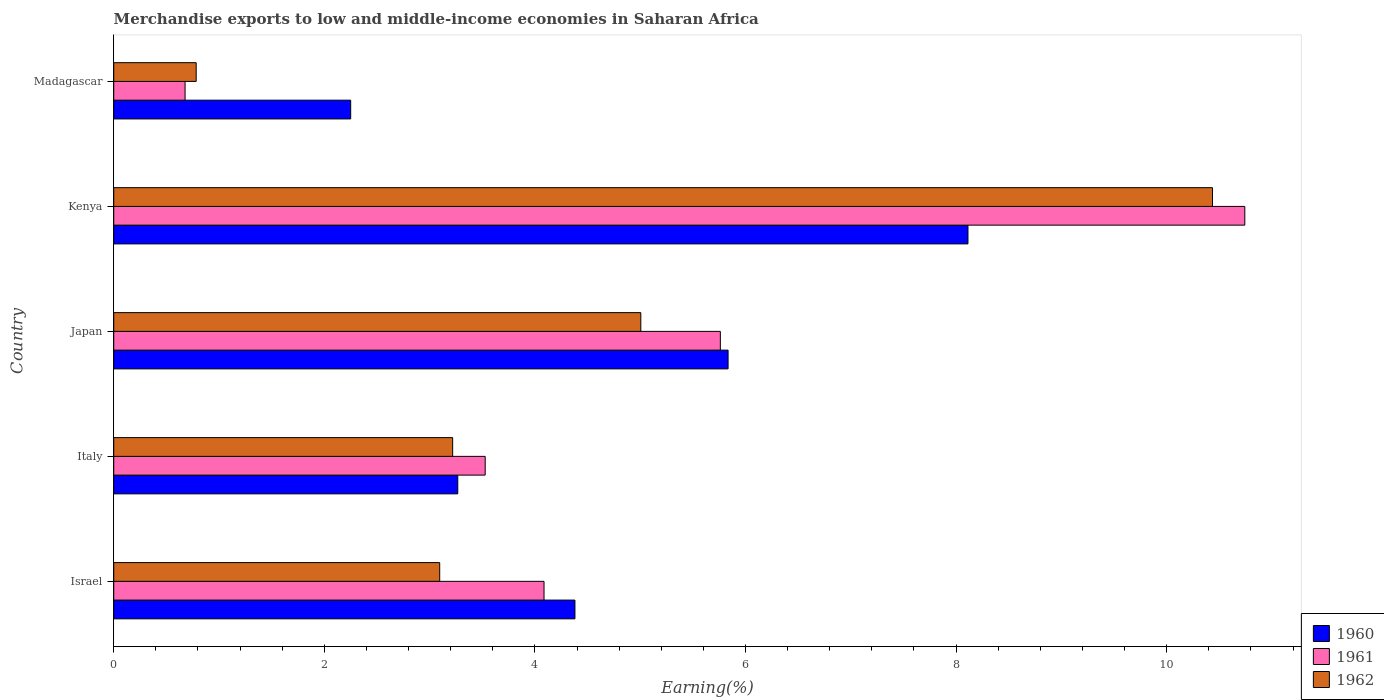How many groups of bars are there?
Make the answer very short. 5. Are the number of bars on each tick of the Y-axis equal?
Your response must be concise. Yes. How many bars are there on the 2nd tick from the top?
Ensure brevity in your answer.  3. What is the label of the 2nd group of bars from the top?
Provide a short and direct response. Kenya. In how many cases, is the number of bars for a given country not equal to the number of legend labels?
Keep it short and to the point. 0. What is the percentage of amount earned from merchandise exports in 1961 in Israel?
Provide a short and direct response. 4.09. Across all countries, what is the maximum percentage of amount earned from merchandise exports in 1962?
Your answer should be compact. 10.44. Across all countries, what is the minimum percentage of amount earned from merchandise exports in 1960?
Ensure brevity in your answer.  2.25. In which country was the percentage of amount earned from merchandise exports in 1961 maximum?
Make the answer very short. Kenya. In which country was the percentage of amount earned from merchandise exports in 1960 minimum?
Provide a succinct answer. Madagascar. What is the total percentage of amount earned from merchandise exports in 1962 in the graph?
Your answer should be compact. 22.54. What is the difference between the percentage of amount earned from merchandise exports in 1962 in Israel and that in Japan?
Provide a succinct answer. -1.91. What is the difference between the percentage of amount earned from merchandise exports in 1960 in Israel and the percentage of amount earned from merchandise exports in 1961 in Madagascar?
Ensure brevity in your answer.  3.7. What is the average percentage of amount earned from merchandise exports in 1960 per country?
Your response must be concise. 4.77. What is the difference between the percentage of amount earned from merchandise exports in 1960 and percentage of amount earned from merchandise exports in 1961 in Italy?
Provide a short and direct response. -0.26. What is the ratio of the percentage of amount earned from merchandise exports in 1962 in Israel to that in Japan?
Provide a succinct answer. 0.62. Is the percentage of amount earned from merchandise exports in 1960 in Italy less than that in Japan?
Your answer should be compact. Yes. Is the difference between the percentage of amount earned from merchandise exports in 1960 in Italy and Madagascar greater than the difference between the percentage of amount earned from merchandise exports in 1961 in Italy and Madagascar?
Make the answer very short. No. What is the difference between the highest and the second highest percentage of amount earned from merchandise exports in 1961?
Your response must be concise. 4.98. What is the difference between the highest and the lowest percentage of amount earned from merchandise exports in 1961?
Provide a short and direct response. 10.06. What does the 2nd bar from the top in Madagascar represents?
Provide a succinct answer. 1961. Is it the case that in every country, the sum of the percentage of amount earned from merchandise exports in 1960 and percentage of amount earned from merchandise exports in 1961 is greater than the percentage of amount earned from merchandise exports in 1962?
Provide a short and direct response. Yes. How many bars are there?
Ensure brevity in your answer.  15. How many countries are there in the graph?
Provide a succinct answer. 5. Does the graph contain any zero values?
Make the answer very short. No. How many legend labels are there?
Provide a succinct answer. 3. How are the legend labels stacked?
Offer a terse response. Vertical. What is the title of the graph?
Your answer should be very brief. Merchandise exports to low and middle-income economies in Saharan Africa. What is the label or title of the X-axis?
Your answer should be very brief. Earning(%). What is the Earning(%) of 1960 in Israel?
Keep it short and to the point. 4.38. What is the Earning(%) in 1961 in Israel?
Keep it short and to the point. 4.09. What is the Earning(%) of 1962 in Israel?
Ensure brevity in your answer.  3.1. What is the Earning(%) in 1960 in Italy?
Your answer should be very brief. 3.27. What is the Earning(%) in 1961 in Italy?
Your answer should be very brief. 3.53. What is the Earning(%) of 1962 in Italy?
Your response must be concise. 3.22. What is the Earning(%) in 1960 in Japan?
Offer a very short reply. 5.83. What is the Earning(%) in 1961 in Japan?
Provide a succinct answer. 5.76. What is the Earning(%) in 1962 in Japan?
Offer a very short reply. 5.01. What is the Earning(%) of 1960 in Kenya?
Give a very brief answer. 8.11. What is the Earning(%) of 1961 in Kenya?
Make the answer very short. 10.74. What is the Earning(%) of 1962 in Kenya?
Provide a succinct answer. 10.44. What is the Earning(%) in 1960 in Madagascar?
Make the answer very short. 2.25. What is the Earning(%) in 1961 in Madagascar?
Give a very brief answer. 0.68. What is the Earning(%) of 1962 in Madagascar?
Give a very brief answer. 0.78. Across all countries, what is the maximum Earning(%) of 1960?
Ensure brevity in your answer.  8.11. Across all countries, what is the maximum Earning(%) of 1961?
Provide a succinct answer. 10.74. Across all countries, what is the maximum Earning(%) in 1962?
Ensure brevity in your answer.  10.44. Across all countries, what is the minimum Earning(%) of 1960?
Provide a short and direct response. 2.25. Across all countries, what is the minimum Earning(%) in 1961?
Give a very brief answer. 0.68. Across all countries, what is the minimum Earning(%) of 1962?
Your answer should be very brief. 0.78. What is the total Earning(%) of 1960 in the graph?
Your answer should be compact. 23.85. What is the total Earning(%) of 1961 in the graph?
Keep it short and to the point. 24.8. What is the total Earning(%) of 1962 in the graph?
Keep it short and to the point. 22.54. What is the difference between the Earning(%) of 1960 in Israel and that in Italy?
Offer a terse response. 1.11. What is the difference between the Earning(%) in 1961 in Israel and that in Italy?
Give a very brief answer. 0.56. What is the difference between the Earning(%) in 1962 in Israel and that in Italy?
Make the answer very short. -0.12. What is the difference between the Earning(%) of 1960 in Israel and that in Japan?
Give a very brief answer. -1.45. What is the difference between the Earning(%) of 1961 in Israel and that in Japan?
Your answer should be very brief. -1.67. What is the difference between the Earning(%) in 1962 in Israel and that in Japan?
Provide a succinct answer. -1.91. What is the difference between the Earning(%) in 1960 in Israel and that in Kenya?
Keep it short and to the point. -3.73. What is the difference between the Earning(%) of 1961 in Israel and that in Kenya?
Offer a very short reply. -6.66. What is the difference between the Earning(%) in 1962 in Israel and that in Kenya?
Your answer should be very brief. -7.34. What is the difference between the Earning(%) in 1960 in Israel and that in Madagascar?
Provide a succinct answer. 2.13. What is the difference between the Earning(%) of 1961 in Israel and that in Madagascar?
Keep it short and to the point. 3.41. What is the difference between the Earning(%) in 1962 in Israel and that in Madagascar?
Provide a short and direct response. 2.31. What is the difference between the Earning(%) of 1960 in Italy and that in Japan?
Provide a short and direct response. -2.57. What is the difference between the Earning(%) of 1961 in Italy and that in Japan?
Keep it short and to the point. -2.23. What is the difference between the Earning(%) of 1962 in Italy and that in Japan?
Your answer should be very brief. -1.79. What is the difference between the Earning(%) of 1960 in Italy and that in Kenya?
Offer a very short reply. -4.85. What is the difference between the Earning(%) in 1961 in Italy and that in Kenya?
Provide a succinct answer. -7.21. What is the difference between the Earning(%) of 1962 in Italy and that in Kenya?
Provide a short and direct response. -7.22. What is the difference between the Earning(%) in 1960 in Italy and that in Madagascar?
Provide a succinct answer. 1.02. What is the difference between the Earning(%) of 1961 in Italy and that in Madagascar?
Keep it short and to the point. 2.85. What is the difference between the Earning(%) in 1962 in Italy and that in Madagascar?
Provide a succinct answer. 2.44. What is the difference between the Earning(%) of 1960 in Japan and that in Kenya?
Keep it short and to the point. -2.28. What is the difference between the Earning(%) in 1961 in Japan and that in Kenya?
Keep it short and to the point. -4.98. What is the difference between the Earning(%) of 1962 in Japan and that in Kenya?
Your response must be concise. -5.43. What is the difference between the Earning(%) in 1960 in Japan and that in Madagascar?
Provide a short and direct response. 3.58. What is the difference between the Earning(%) of 1961 in Japan and that in Madagascar?
Ensure brevity in your answer.  5.08. What is the difference between the Earning(%) of 1962 in Japan and that in Madagascar?
Your response must be concise. 4.22. What is the difference between the Earning(%) in 1960 in Kenya and that in Madagascar?
Ensure brevity in your answer.  5.86. What is the difference between the Earning(%) in 1961 in Kenya and that in Madagascar?
Provide a short and direct response. 10.06. What is the difference between the Earning(%) of 1962 in Kenya and that in Madagascar?
Make the answer very short. 9.65. What is the difference between the Earning(%) in 1960 in Israel and the Earning(%) in 1961 in Italy?
Offer a terse response. 0.85. What is the difference between the Earning(%) in 1960 in Israel and the Earning(%) in 1962 in Italy?
Offer a very short reply. 1.16. What is the difference between the Earning(%) in 1961 in Israel and the Earning(%) in 1962 in Italy?
Offer a very short reply. 0.87. What is the difference between the Earning(%) in 1960 in Israel and the Earning(%) in 1961 in Japan?
Give a very brief answer. -1.38. What is the difference between the Earning(%) of 1960 in Israel and the Earning(%) of 1962 in Japan?
Offer a very short reply. -0.63. What is the difference between the Earning(%) of 1961 in Israel and the Earning(%) of 1962 in Japan?
Provide a succinct answer. -0.92. What is the difference between the Earning(%) in 1960 in Israel and the Earning(%) in 1961 in Kenya?
Keep it short and to the point. -6.36. What is the difference between the Earning(%) of 1960 in Israel and the Earning(%) of 1962 in Kenya?
Keep it short and to the point. -6.06. What is the difference between the Earning(%) of 1961 in Israel and the Earning(%) of 1962 in Kenya?
Provide a short and direct response. -6.35. What is the difference between the Earning(%) in 1960 in Israel and the Earning(%) in 1961 in Madagascar?
Give a very brief answer. 3.7. What is the difference between the Earning(%) in 1960 in Israel and the Earning(%) in 1962 in Madagascar?
Provide a succinct answer. 3.6. What is the difference between the Earning(%) in 1961 in Israel and the Earning(%) in 1962 in Madagascar?
Make the answer very short. 3.3. What is the difference between the Earning(%) in 1960 in Italy and the Earning(%) in 1961 in Japan?
Your answer should be very brief. -2.49. What is the difference between the Earning(%) of 1960 in Italy and the Earning(%) of 1962 in Japan?
Provide a short and direct response. -1.74. What is the difference between the Earning(%) in 1961 in Italy and the Earning(%) in 1962 in Japan?
Ensure brevity in your answer.  -1.48. What is the difference between the Earning(%) of 1960 in Italy and the Earning(%) of 1961 in Kenya?
Your answer should be compact. -7.47. What is the difference between the Earning(%) in 1960 in Italy and the Earning(%) in 1962 in Kenya?
Offer a very short reply. -7.17. What is the difference between the Earning(%) of 1961 in Italy and the Earning(%) of 1962 in Kenya?
Your response must be concise. -6.91. What is the difference between the Earning(%) in 1960 in Italy and the Earning(%) in 1961 in Madagascar?
Provide a short and direct response. 2.59. What is the difference between the Earning(%) in 1960 in Italy and the Earning(%) in 1962 in Madagascar?
Make the answer very short. 2.48. What is the difference between the Earning(%) in 1961 in Italy and the Earning(%) in 1962 in Madagascar?
Your answer should be compact. 2.74. What is the difference between the Earning(%) of 1960 in Japan and the Earning(%) of 1961 in Kenya?
Offer a terse response. -4.91. What is the difference between the Earning(%) of 1960 in Japan and the Earning(%) of 1962 in Kenya?
Ensure brevity in your answer.  -4.6. What is the difference between the Earning(%) in 1961 in Japan and the Earning(%) in 1962 in Kenya?
Provide a short and direct response. -4.67. What is the difference between the Earning(%) in 1960 in Japan and the Earning(%) in 1961 in Madagascar?
Your response must be concise. 5.16. What is the difference between the Earning(%) of 1960 in Japan and the Earning(%) of 1962 in Madagascar?
Your answer should be very brief. 5.05. What is the difference between the Earning(%) of 1961 in Japan and the Earning(%) of 1962 in Madagascar?
Your response must be concise. 4.98. What is the difference between the Earning(%) of 1960 in Kenya and the Earning(%) of 1961 in Madagascar?
Keep it short and to the point. 7.44. What is the difference between the Earning(%) of 1960 in Kenya and the Earning(%) of 1962 in Madagascar?
Offer a very short reply. 7.33. What is the difference between the Earning(%) of 1961 in Kenya and the Earning(%) of 1962 in Madagascar?
Keep it short and to the point. 9.96. What is the average Earning(%) in 1960 per country?
Make the answer very short. 4.77. What is the average Earning(%) of 1961 per country?
Make the answer very short. 4.96. What is the average Earning(%) in 1962 per country?
Make the answer very short. 4.51. What is the difference between the Earning(%) of 1960 and Earning(%) of 1961 in Israel?
Give a very brief answer. 0.29. What is the difference between the Earning(%) of 1960 and Earning(%) of 1962 in Israel?
Give a very brief answer. 1.28. What is the difference between the Earning(%) in 1961 and Earning(%) in 1962 in Israel?
Ensure brevity in your answer.  0.99. What is the difference between the Earning(%) in 1960 and Earning(%) in 1961 in Italy?
Your response must be concise. -0.26. What is the difference between the Earning(%) of 1960 and Earning(%) of 1962 in Italy?
Ensure brevity in your answer.  0.05. What is the difference between the Earning(%) in 1961 and Earning(%) in 1962 in Italy?
Provide a short and direct response. 0.31. What is the difference between the Earning(%) of 1960 and Earning(%) of 1961 in Japan?
Your response must be concise. 0.07. What is the difference between the Earning(%) of 1960 and Earning(%) of 1962 in Japan?
Offer a terse response. 0.83. What is the difference between the Earning(%) of 1961 and Earning(%) of 1962 in Japan?
Keep it short and to the point. 0.76. What is the difference between the Earning(%) in 1960 and Earning(%) in 1961 in Kenya?
Make the answer very short. -2.63. What is the difference between the Earning(%) in 1960 and Earning(%) in 1962 in Kenya?
Make the answer very short. -2.32. What is the difference between the Earning(%) in 1961 and Earning(%) in 1962 in Kenya?
Offer a very short reply. 0.31. What is the difference between the Earning(%) in 1960 and Earning(%) in 1961 in Madagascar?
Provide a short and direct response. 1.57. What is the difference between the Earning(%) in 1960 and Earning(%) in 1962 in Madagascar?
Your answer should be very brief. 1.47. What is the difference between the Earning(%) in 1961 and Earning(%) in 1962 in Madagascar?
Provide a short and direct response. -0.11. What is the ratio of the Earning(%) of 1960 in Israel to that in Italy?
Provide a short and direct response. 1.34. What is the ratio of the Earning(%) of 1961 in Israel to that in Italy?
Provide a short and direct response. 1.16. What is the ratio of the Earning(%) in 1962 in Israel to that in Italy?
Offer a terse response. 0.96. What is the ratio of the Earning(%) of 1960 in Israel to that in Japan?
Your answer should be very brief. 0.75. What is the ratio of the Earning(%) in 1961 in Israel to that in Japan?
Give a very brief answer. 0.71. What is the ratio of the Earning(%) in 1962 in Israel to that in Japan?
Your answer should be very brief. 0.62. What is the ratio of the Earning(%) of 1960 in Israel to that in Kenya?
Offer a terse response. 0.54. What is the ratio of the Earning(%) of 1961 in Israel to that in Kenya?
Offer a very short reply. 0.38. What is the ratio of the Earning(%) of 1962 in Israel to that in Kenya?
Your response must be concise. 0.3. What is the ratio of the Earning(%) of 1960 in Israel to that in Madagascar?
Your answer should be very brief. 1.95. What is the ratio of the Earning(%) of 1961 in Israel to that in Madagascar?
Make the answer very short. 6.03. What is the ratio of the Earning(%) in 1962 in Israel to that in Madagascar?
Keep it short and to the point. 3.95. What is the ratio of the Earning(%) of 1960 in Italy to that in Japan?
Offer a terse response. 0.56. What is the ratio of the Earning(%) of 1961 in Italy to that in Japan?
Provide a short and direct response. 0.61. What is the ratio of the Earning(%) of 1962 in Italy to that in Japan?
Your answer should be compact. 0.64. What is the ratio of the Earning(%) of 1960 in Italy to that in Kenya?
Provide a short and direct response. 0.4. What is the ratio of the Earning(%) of 1961 in Italy to that in Kenya?
Provide a short and direct response. 0.33. What is the ratio of the Earning(%) of 1962 in Italy to that in Kenya?
Offer a very short reply. 0.31. What is the ratio of the Earning(%) in 1960 in Italy to that in Madagascar?
Provide a succinct answer. 1.45. What is the ratio of the Earning(%) of 1961 in Italy to that in Madagascar?
Ensure brevity in your answer.  5.21. What is the ratio of the Earning(%) of 1962 in Italy to that in Madagascar?
Provide a succinct answer. 4.11. What is the ratio of the Earning(%) of 1960 in Japan to that in Kenya?
Keep it short and to the point. 0.72. What is the ratio of the Earning(%) of 1961 in Japan to that in Kenya?
Provide a short and direct response. 0.54. What is the ratio of the Earning(%) of 1962 in Japan to that in Kenya?
Provide a succinct answer. 0.48. What is the ratio of the Earning(%) of 1960 in Japan to that in Madagascar?
Ensure brevity in your answer.  2.59. What is the ratio of the Earning(%) of 1961 in Japan to that in Madagascar?
Provide a succinct answer. 8.5. What is the ratio of the Earning(%) of 1962 in Japan to that in Madagascar?
Give a very brief answer. 6.39. What is the ratio of the Earning(%) of 1960 in Kenya to that in Madagascar?
Keep it short and to the point. 3.61. What is the ratio of the Earning(%) of 1961 in Kenya to that in Madagascar?
Your response must be concise. 15.86. What is the ratio of the Earning(%) of 1962 in Kenya to that in Madagascar?
Your answer should be compact. 13.33. What is the difference between the highest and the second highest Earning(%) of 1960?
Your answer should be very brief. 2.28. What is the difference between the highest and the second highest Earning(%) of 1961?
Make the answer very short. 4.98. What is the difference between the highest and the second highest Earning(%) in 1962?
Your answer should be compact. 5.43. What is the difference between the highest and the lowest Earning(%) of 1960?
Offer a very short reply. 5.86. What is the difference between the highest and the lowest Earning(%) in 1961?
Provide a short and direct response. 10.06. What is the difference between the highest and the lowest Earning(%) of 1962?
Your response must be concise. 9.65. 